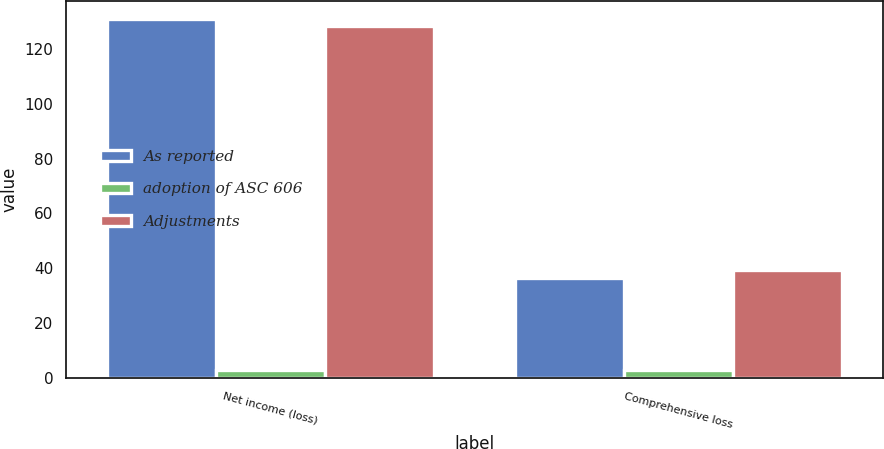<chart> <loc_0><loc_0><loc_500><loc_500><stacked_bar_chart><ecel><fcel>Net income (loss)<fcel>Comprehensive loss<nl><fcel>As reported<fcel>131<fcel>36.5<nl><fcel>adoption of ASC 606<fcel>2.8<fcel>2.8<nl><fcel>Adjustments<fcel>128.2<fcel>39.3<nl></chart> 